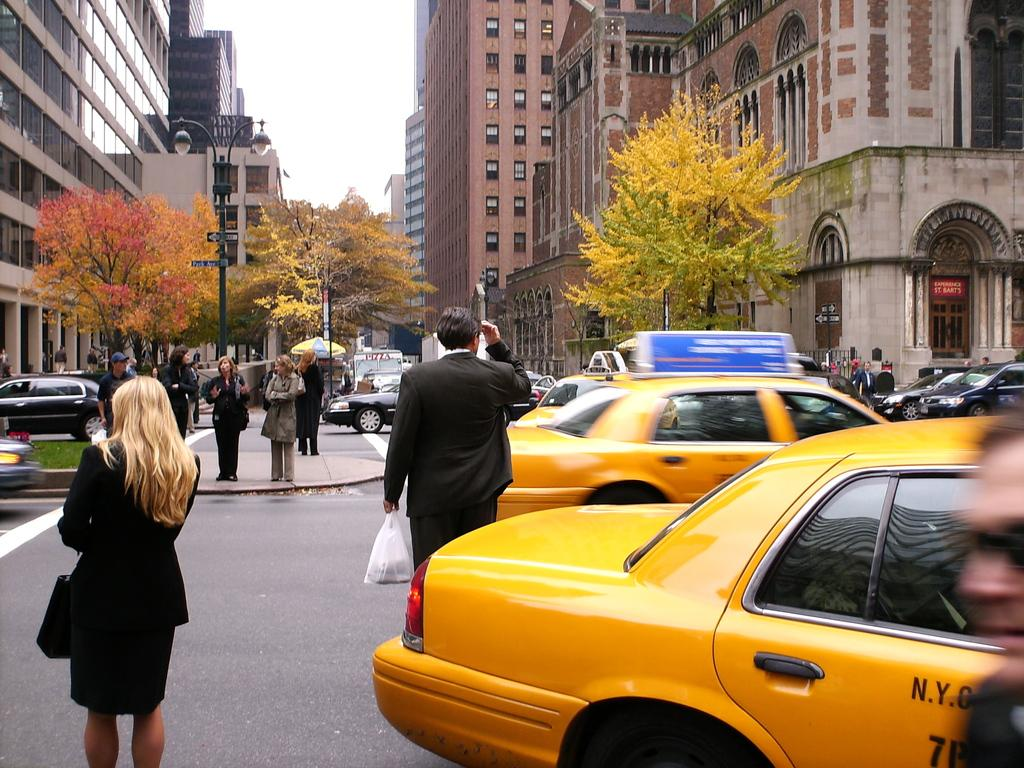<image>
Give a short and clear explanation of the subsequent image. a lady next to a taxi with the letter N on it 